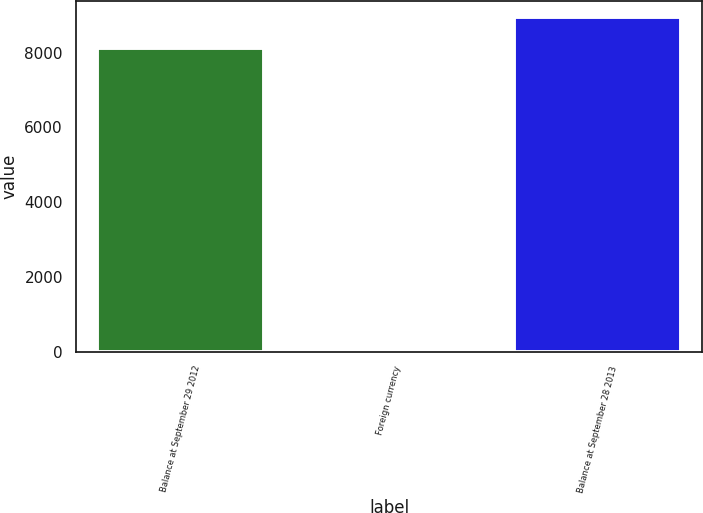Convert chart. <chart><loc_0><loc_0><loc_500><loc_500><bar_chart><fcel>Balance at September 29 2012<fcel>Foreign currency<fcel>Balance at September 28 2013<nl><fcel>8125<fcel>28<fcel>8937.5<nl></chart> 